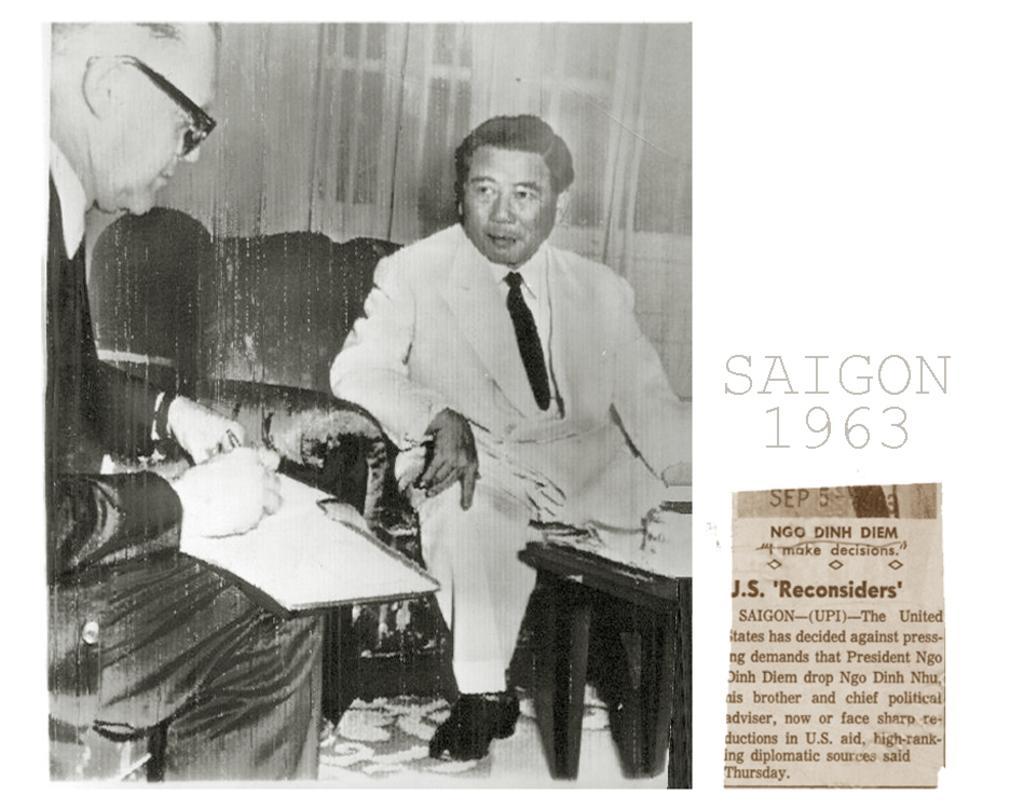Can you describe this image briefly? In this picture we can observe two men sitting in the sofa. One of the men is wearing spectacles and holding a book in his hand and writing on it. In the right side we can observe an article in the newspaper. This is a black and white image. In the background there are curtains and doors. 